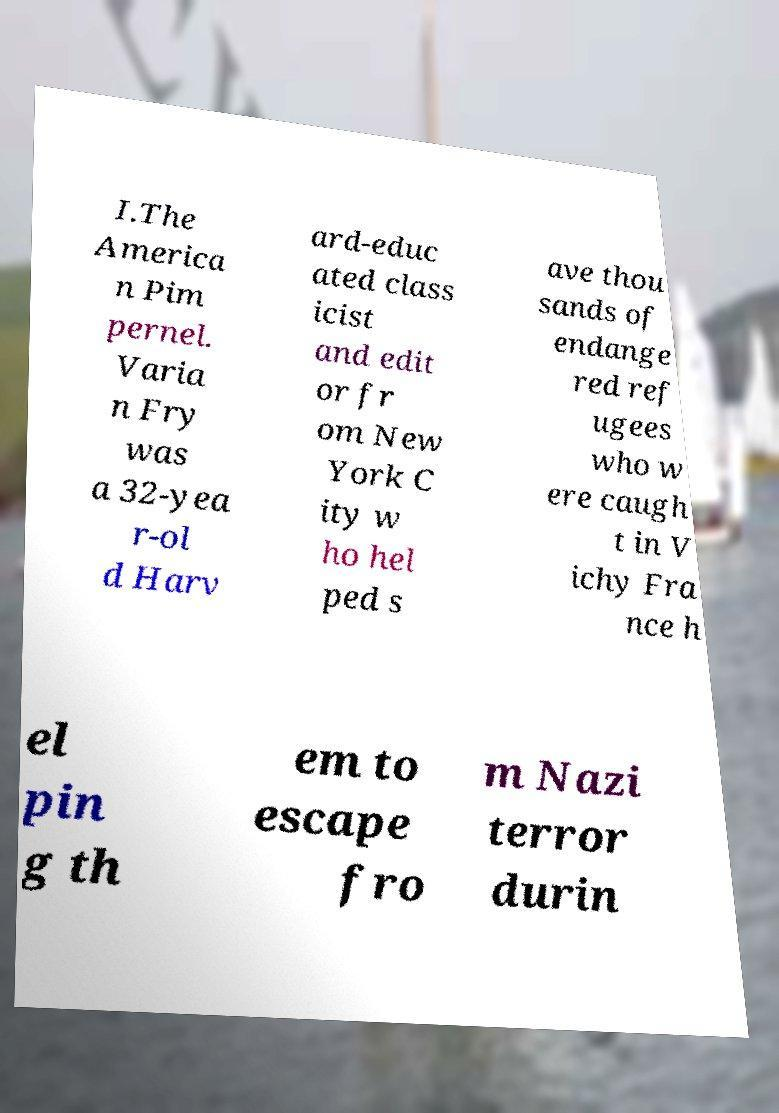For documentation purposes, I need the text within this image transcribed. Could you provide that? I.The America n Pim pernel. Varia n Fry was a 32-yea r-ol d Harv ard-educ ated class icist and edit or fr om New York C ity w ho hel ped s ave thou sands of endange red ref ugees who w ere caugh t in V ichy Fra nce h el pin g th em to escape fro m Nazi terror durin 